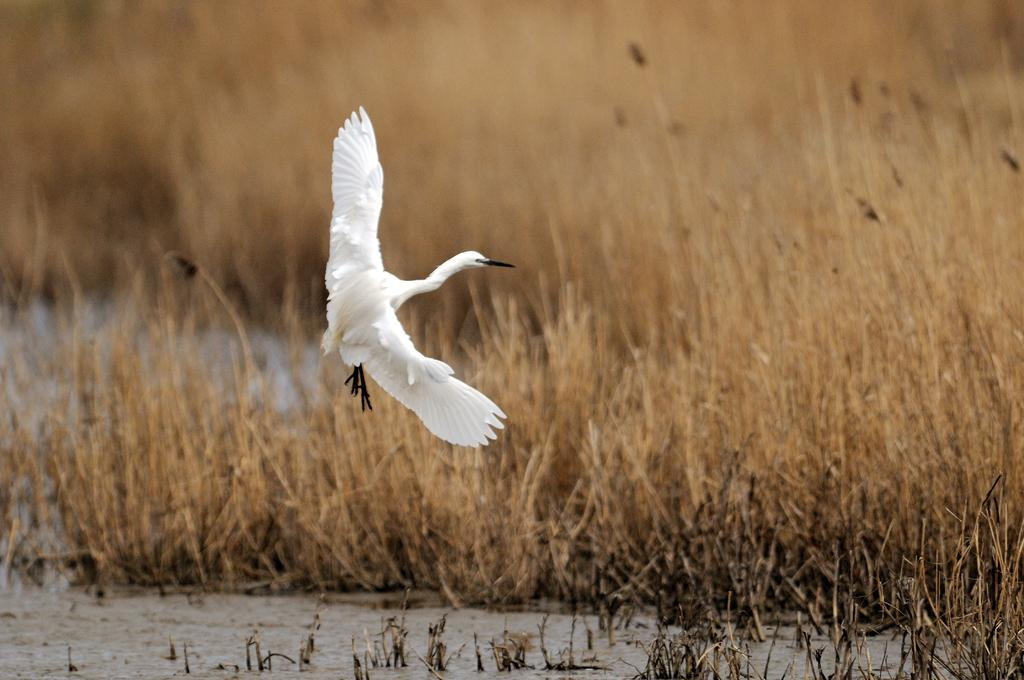What type of animal can be seen in the image? There is a white color bird in the image. What is the bird doing in the image? The bird is flying. What type of vegetation is visible in the image? Dry grass is visible in the image. What natural element is present in the image? There is water in the image. How many ladybugs are crawling on the page in the image? There are no ladybugs or pages present in the image; it features a bird flying over dry grass and water. 